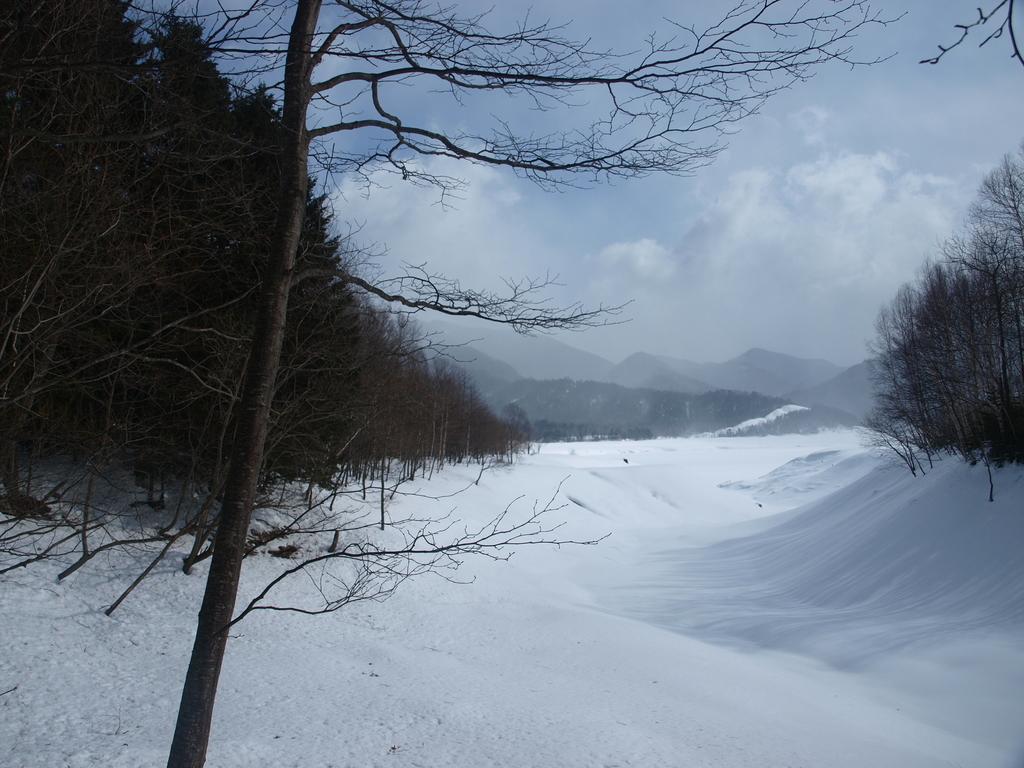Can you describe this image briefly? This image consists of many trees. At the bottom, there is snow. At the top, there are clouds in the sky. In the background, there are mountains. 